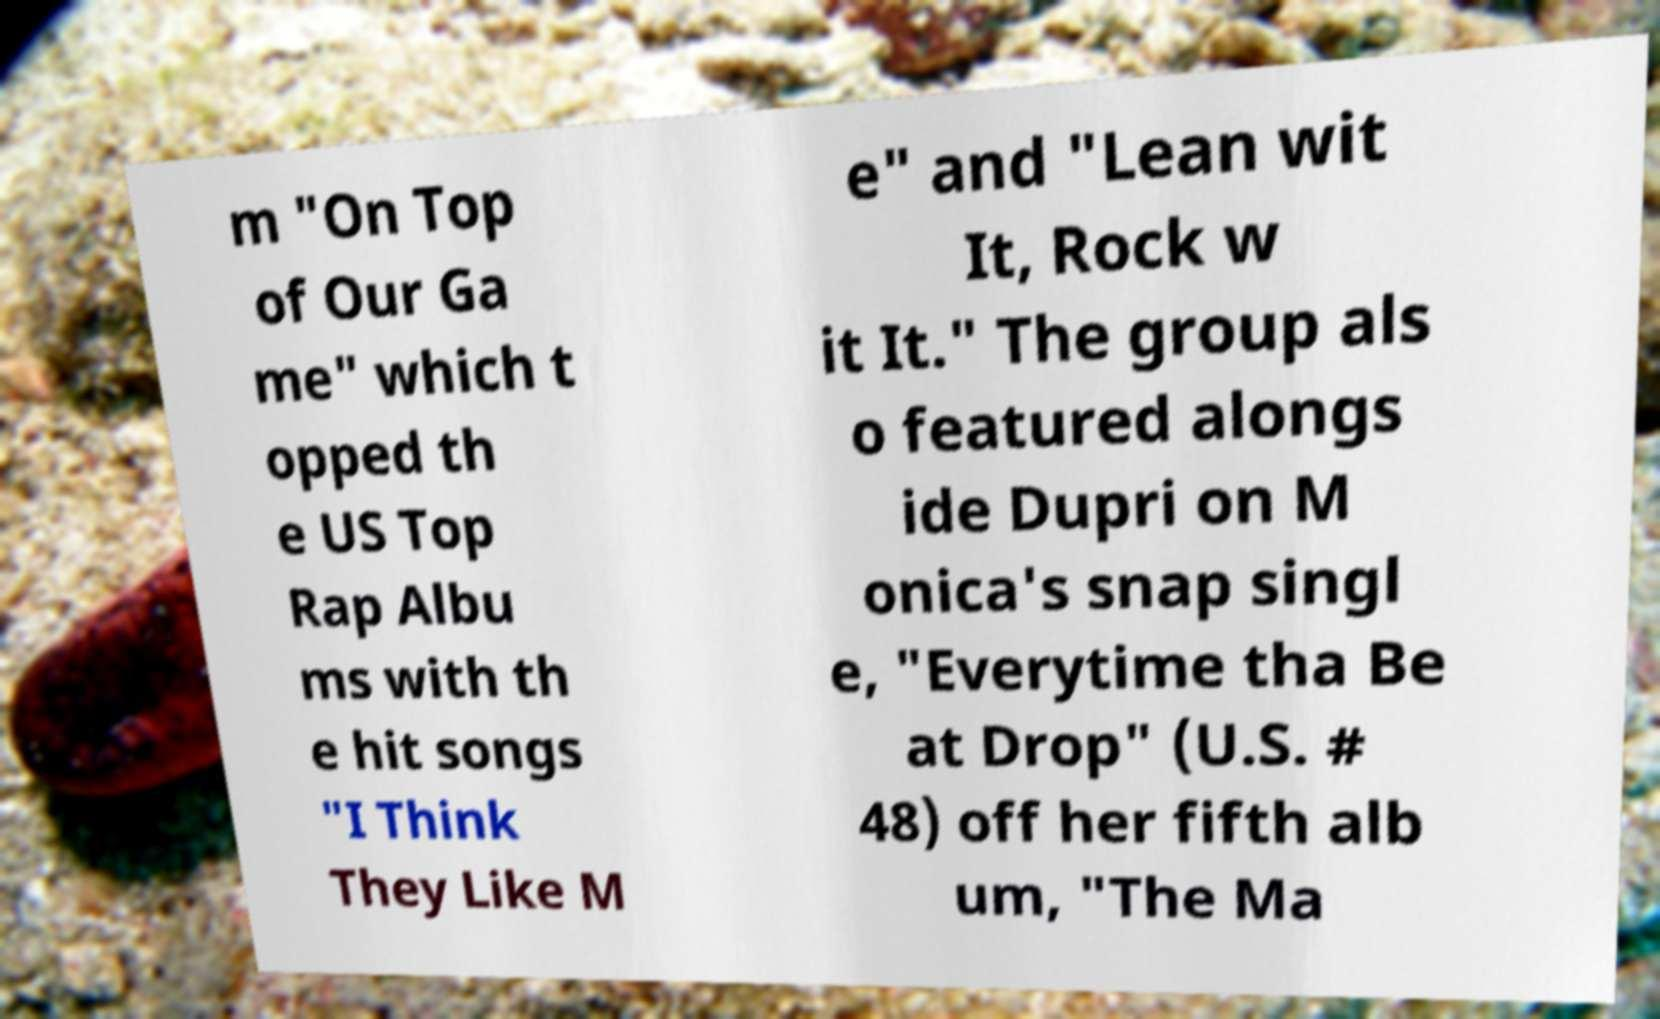Please identify and transcribe the text found in this image. m "On Top of Our Ga me" which t opped th e US Top Rap Albu ms with th e hit songs "I Think They Like M e" and "Lean wit It, Rock w it It." The group als o featured alongs ide Dupri on M onica's snap singl e, "Everytime tha Be at Drop" (U.S. # 48) off her fifth alb um, "The Ma 